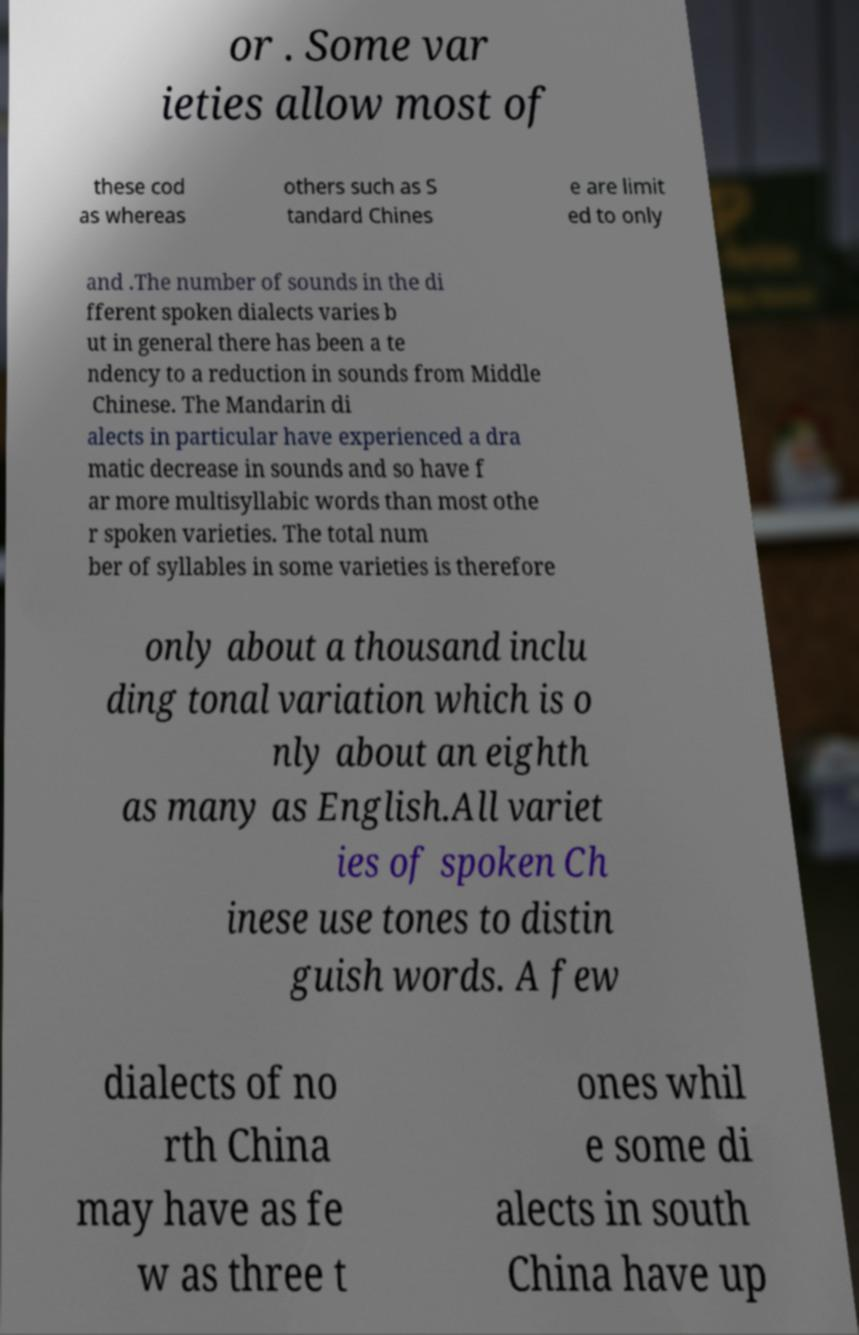Could you assist in decoding the text presented in this image and type it out clearly? or . Some var ieties allow most of these cod as whereas others such as S tandard Chines e are limit ed to only and .The number of sounds in the di fferent spoken dialects varies b ut in general there has been a te ndency to a reduction in sounds from Middle Chinese. The Mandarin di alects in particular have experienced a dra matic decrease in sounds and so have f ar more multisyllabic words than most othe r spoken varieties. The total num ber of syllables in some varieties is therefore only about a thousand inclu ding tonal variation which is o nly about an eighth as many as English.All variet ies of spoken Ch inese use tones to distin guish words. A few dialects of no rth China may have as fe w as three t ones whil e some di alects in south China have up 